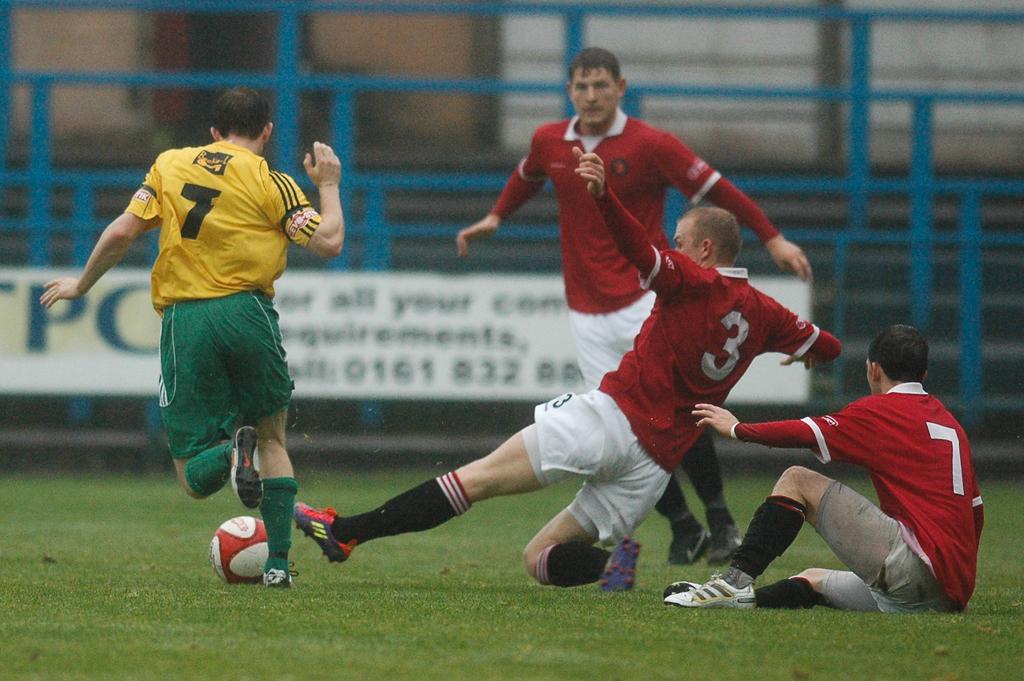What number is on the yellow shirt?
Give a very brief answer. 7. What number is the red jersey in the middle?
Give a very brief answer. 3. 